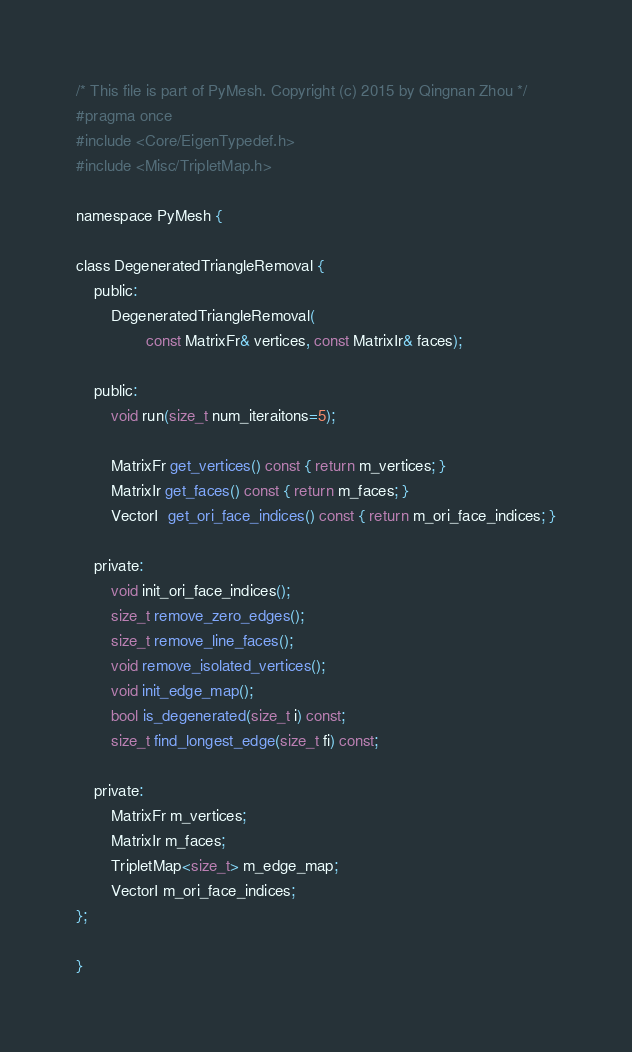Convert code to text. <code><loc_0><loc_0><loc_500><loc_500><_C_>/* This file is part of PyMesh. Copyright (c) 2015 by Qingnan Zhou */
#pragma once
#include <Core/EigenTypedef.h>
#include <Misc/TripletMap.h>

namespace PyMesh {

class DegeneratedTriangleRemoval {
    public:
        DegeneratedTriangleRemoval(
                const MatrixFr& vertices, const MatrixIr& faces);

    public:
        void run(size_t num_iteraitons=5);

        MatrixFr get_vertices() const { return m_vertices; }
        MatrixIr get_faces() const { return m_faces; }
        VectorI  get_ori_face_indices() const { return m_ori_face_indices; }

    private:
        void init_ori_face_indices();
        size_t remove_zero_edges();
        size_t remove_line_faces();
        void remove_isolated_vertices();
        void init_edge_map();
        bool is_degenerated(size_t i) const;
        size_t find_longest_edge(size_t fi) const;

    private:
        MatrixFr m_vertices;
        MatrixIr m_faces;
        TripletMap<size_t> m_edge_map;
        VectorI m_ori_face_indices;
};

}
</code> 